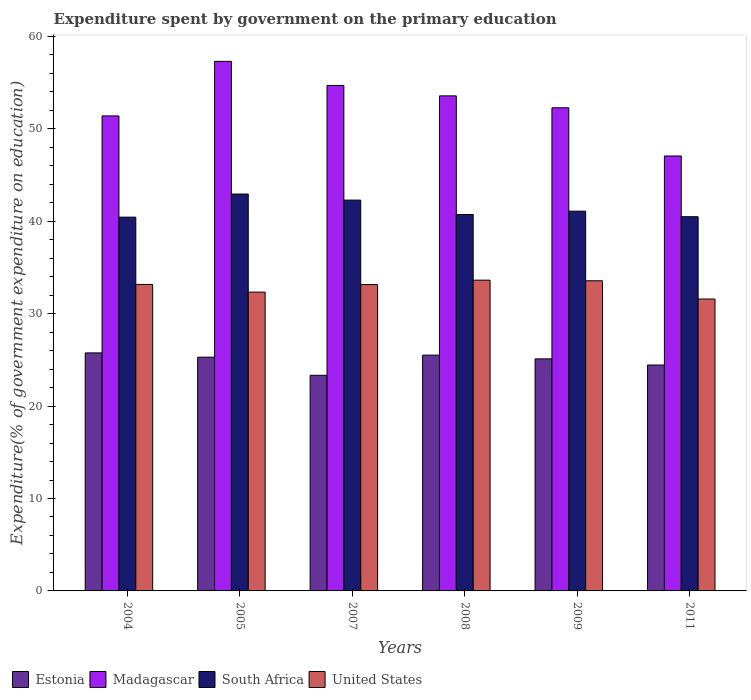How many groups of bars are there?
Provide a short and direct response. 6. What is the expenditure spent by government on the primary education in United States in 2009?
Provide a short and direct response. 33.56. Across all years, what is the maximum expenditure spent by government on the primary education in South Africa?
Provide a succinct answer. 42.95. Across all years, what is the minimum expenditure spent by government on the primary education in Estonia?
Ensure brevity in your answer.  23.33. In which year was the expenditure spent by government on the primary education in United States maximum?
Offer a very short reply. 2008. What is the total expenditure spent by government on the primary education in United States in the graph?
Keep it short and to the point. 197.42. What is the difference between the expenditure spent by government on the primary education in Estonia in 2005 and that in 2009?
Give a very brief answer. 0.18. What is the difference between the expenditure spent by government on the primary education in United States in 2011 and the expenditure spent by government on the primary education in Madagascar in 2009?
Give a very brief answer. -20.7. What is the average expenditure spent by government on the primary education in South Africa per year?
Your answer should be compact. 41.33. In the year 2011, what is the difference between the expenditure spent by government on the primary education in Madagascar and expenditure spent by government on the primary education in Estonia?
Provide a short and direct response. 22.62. In how many years, is the expenditure spent by government on the primary education in South Africa greater than 36 %?
Give a very brief answer. 6. What is the ratio of the expenditure spent by government on the primary education in Estonia in 2004 to that in 2009?
Give a very brief answer. 1.03. Is the expenditure spent by government on the primary education in Madagascar in 2008 less than that in 2011?
Offer a very short reply. No. What is the difference between the highest and the second highest expenditure spent by government on the primary education in South Africa?
Keep it short and to the point. 0.66. What is the difference between the highest and the lowest expenditure spent by government on the primary education in South Africa?
Your answer should be compact. 2.5. What does the 2nd bar from the left in 2011 represents?
Offer a terse response. Madagascar. What does the 3rd bar from the right in 2008 represents?
Your response must be concise. Madagascar. Is it the case that in every year, the sum of the expenditure spent by government on the primary education in United States and expenditure spent by government on the primary education in South Africa is greater than the expenditure spent by government on the primary education in Estonia?
Ensure brevity in your answer.  Yes. How many bars are there?
Provide a succinct answer. 24. How many years are there in the graph?
Your answer should be compact. 6. What is the difference between two consecutive major ticks on the Y-axis?
Offer a terse response. 10. Are the values on the major ticks of Y-axis written in scientific E-notation?
Your response must be concise. No. How many legend labels are there?
Give a very brief answer. 4. How are the legend labels stacked?
Your answer should be very brief. Horizontal. What is the title of the graph?
Give a very brief answer. Expenditure spent by government on the primary education. What is the label or title of the Y-axis?
Offer a very short reply. Expenditure(% of government expenditure on education). What is the Expenditure(% of government expenditure on education) in Estonia in 2004?
Keep it short and to the point. 25.76. What is the Expenditure(% of government expenditure on education) of Madagascar in 2004?
Provide a succinct answer. 51.4. What is the Expenditure(% of government expenditure on education) of South Africa in 2004?
Offer a very short reply. 40.45. What is the Expenditure(% of government expenditure on education) of United States in 2004?
Provide a succinct answer. 33.16. What is the Expenditure(% of government expenditure on education) of Estonia in 2005?
Provide a succinct answer. 25.3. What is the Expenditure(% of government expenditure on education) of Madagascar in 2005?
Offer a very short reply. 57.31. What is the Expenditure(% of government expenditure on education) of South Africa in 2005?
Your answer should be compact. 42.95. What is the Expenditure(% of government expenditure on education) in United States in 2005?
Keep it short and to the point. 32.33. What is the Expenditure(% of government expenditure on education) of Estonia in 2007?
Ensure brevity in your answer.  23.33. What is the Expenditure(% of government expenditure on education) in Madagascar in 2007?
Keep it short and to the point. 54.7. What is the Expenditure(% of government expenditure on education) of South Africa in 2007?
Provide a succinct answer. 42.29. What is the Expenditure(% of government expenditure on education) in United States in 2007?
Keep it short and to the point. 33.15. What is the Expenditure(% of government expenditure on education) of Estonia in 2008?
Ensure brevity in your answer.  25.52. What is the Expenditure(% of government expenditure on education) in Madagascar in 2008?
Make the answer very short. 53.57. What is the Expenditure(% of government expenditure on education) in South Africa in 2008?
Provide a succinct answer. 40.73. What is the Expenditure(% of government expenditure on education) of United States in 2008?
Your answer should be compact. 33.63. What is the Expenditure(% of government expenditure on education) of Estonia in 2009?
Your answer should be very brief. 25.11. What is the Expenditure(% of government expenditure on education) of Madagascar in 2009?
Offer a very short reply. 52.28. What is the Expenditure(% of government expenditure on education) in South Africa in 2009?
Provide a short and direct response. 41.09. What is the Expenditure(% of government expenditure on education) of United States in 2009?
Your answer should be very brief. 33.56. What is the Expenditure(% of government expenditure on education) of Estonia in 2011?
Offer a very short reply. 24.45. What is the Expenditure(% of government expenditure on education) in Madagascar in 2011?
Give a very brief answer. 47.07. What is the Expenditure(% of government expenditure on education) of South Africa in 2011?
Provide a short and direct response. 40.49. What is the Expenditure(% of government expenditure on education) of United States in 2011?
Your answer should be very brief. 31.59. Across all years, what is the maximum Expenditure(% of government expenditure on education) of Estonia?
Keep it short and to the point. 25.76. Across all years, what is the maximum Expenditure(% of government expenditure on education) in Madagascar?
Provide a short and direct response. 57.31. Across all years, what is the maximum Expenditure(% of government expenditure on education) of South Africa?
Your response must be concise. 42.95. Across all years, what is the maximum Expenditure(% of government expenditure on education) in United States?
Your answer should be compact. 33.63. Across all years, what is the minimum Expenditure(% of government expenditure on education) of Estonia?
Offer a terse response. 23.33. Across all years, what is the minimum Expenditure(% of government expenditure on education) of Madagascar?
Offer a terse response. 47.07. Across all years, what is the minimum Expenditure(% of government expenditure on education) in South Africa?
Your response must be concise. 40.45. Across all years, what is the minimum Expenditure(% of government expenditure on education) in United States?
Give a very brief answer. 31.59. What is the total Expenditure(% of government expenditure on education) in Estonia in the graph?
Your answer should be compact. 149.46. What is the total Expenditure(% of government expenditure on education) of Madagascar in the graph?
Ensure brevity in your answer.  316.33. What is the total Expenditure(% of government expenditure on education) of South Africa in the graph?
Your answer should be very brief. 248.01. What is the total Expenditure(% of government expenditure on education) in United States in the graph?
Make the answer very short. 197.42. What is the difference between the Expenditure(% of government expenditure on education) in Estonia in 2004 and that in 2005?
Give a very brief answer. 0.46. What is the difference between the Expenditure(% of government expenditure on education) in Madagascar in 2004 and that in 2005?
Keep it short and to the point. -5.9. What is the difference between the Expenditure(% of government expenditure on education) in South Africa in 2004 and that in 2005?
Ensure brevity in your answer.  -2.5. What is the difference between the Expenditure(% of government expenditure on education) in United States in 2004 and that in 2005?
Keep it short and to the point. 0.83. What is the difference between the Expenditure(% of government expenditure on education) in Estonia in 2004 and that in 2007?
Your answer should be very brief. 2.42. What is the difference between the Expenditure(% of government expenditure on education) in Madagascar in 2004 and that in 2007?
Your answer should be compact. -3.3. What is the difference between the Expenditure(% of government expenditure on education) in South Africa in 2004 and that in 2007?
Provide a short and direct response. -1.85. What is the difference between the Expenditure(% of government expenditure on education) of United States in 2004 and that in 2007?
Provide a short and direct response. 0.02. What is the difference between the Expenditure(% of government expenditure on education) in Estonia in 2004 and that in 2008?
Ensure brevity in your answer.  0.24. What is the difference between the Expenditure(% of government expenditure on education) in Madagascar in 2004 and that in 2008?
Provide a short and direct response. -2.17. What is the difference between the Expenditure(% of government expenditure on education) in South Africa in 2004 and that in 2008?
Your answer should be very brief. -0.29. What is the difference between the Expenditure(% of government expenditure on education) in United States in 2004 and that in 2008?
Give a very brief answer. -0.46. What is the difference between the Expenditure(% of government expenditure on education) of Estonia in 2004 and that in 2009?
Your answer should be compact. 0.65. What is the difference between the Expenditure(% of government expenditure on education) in Madagascar in 2004 and that in 2009?
Your response must be concise. -0.88. What is the difference between the Expenditure(% of government expenditure on education) in South Africa in 2004 and that in 2009?
Offer a terse response. -0.65. What is the difference between the Expenditure(% of government expenditure on education) in United States in 2004 and that in 2009?
Your answer should be compact. -0.4. What is the difference between the Expenditure(% of government expenditure on education) of Estonia in 2004 and that in 2011?
Keep it short and to the point. 1.31. What is the difference between the Expenditure(% of government expenditure on education) in Madagascar in 2004 and that in 2011?
Your answer should be very brief. 4.34. What is the difference between the Expenditure(% of government expenditure on education) in South Africa in 2004 and that in 2011?
Provide a short and direct response. -0.05. What is the difference between the Expenditure(% of government expenditure on education) of United States in 2004 and that in 2011?
Your response must be concise. 1.58. What is the difference between the Expenditure(% of government expenditure on education) of Estonia in 2005 and that in 2007?
Your answer should be very brief. 1.96. What is the difference between the Expenditure(% of government expenditure on education) of Madagascar in 2005 and that in 2007?
Make the answer very short. 2.61. What is the difference between the Expenditure(% of government expenditure on education) of South Africa in 2005 and that in 2007?
Your response must be concise. 0.66. What is the difference between the Expenditure(% of government expenditure on education) of United States in 2005 and that in 2007?
Offer a terse response. -0.81. What is the difference between the Expenditure(% of government expenditure on education) of Estonia in 2005 and that in 2008?
Provide a short and direct response. -0.22. What is the difference between the Expenditure(% of government expenditure on education) in Madagascar in 2005 and that in 2008?
Your answer should be compact. 3.73. What is the difference between the Expenditure(% of government expenditure on education) in South Africa in 2005 and that in 2008?
Provide a short and direct response. 2.21. What is the difference between the Expenditure(% of government expenditure on education) of United States in 2005 and that in 2008?
Keep it short and to the point. -1.29. What is the difference between the Expenditure(% of government expenditure on education) of Estonia in 2005 and that in 2009?
Provide a succinct answer. 0.18. What is the difference between the Expenditure(% of government expenditure on education) in Madagascar in 2005 and that in 2009?
Keep it short and to the point. 5.02. What is the difference between the Expenditure(% of government expenditure on education) of South Africa in 2005 and that in 2009?
Your answer should be very brief. 1.85. What is the difference between the Expenditure(% of government expenditure on education) of United States in 2005 and that in 2009?
Give a very brief answer. -1.23. What is the difference between the Expenditure(% of government expenditure on education) of Estonia in 2005 and that in 2011?
Your answer should be very brief. 0.85. What is the difference between the Expenditure(% of government expenditure on education) in Madagascar in 2005 and that in 2011?
Your answer should be very brief. 10.24. What is the difference between the Expenditure(% of government expenditure on education) in South Africa in 2005 and that in 2011?
Keep it short and to the point. 2.45. What is the difference between the Expenditure(% of government expenditure on education) in United States in 2005 and that in 2011?
Offer a very short reply. 0.75. What is the difference between the Expenditure(% of government expenditure on education) of Estonia in 2007 and that in 2008?
Make the answer very short. -2.18. What is the difference between the Expenditure(% of government expenditure on education) of Madagascar in 2007 and that in 2008?
Provide a succinct answer. 1.13. What is the difference between the Expenditure(% of government expenditure on education) in South Africa in 2007 and that in 2008?
Your answer should be very brief. 1.56. What is the difference between the Expenditure(% of government expenditure on education) of United States in 2007 and that in 2008?
Your answer should be very brief. -0.48. What is the difference between the Expenditure(% of government expenditure on education) of Estonia in 2007 and that in 2009?
Offer a very short reply. -1.78. What is the difference between the Expenditure(% of government expenditure on education) of Madagascar in 2007 and that in 2009?
Give a very brief answer. 2.42. What is the difference between the Expenditure(% of government expenditure on education) in South Africa in 2007 and that in 2009?
Ensure brevity in your answer.  1.2. What is the difference between the Expenditure(% of government expenditure on education) in United States in 2007 and that in 2009?
Give a very brief answer. -0.41. What is the difference between the Expenditure(% of government expenditure on education) in Estonia in 2007 and that in 2011?
Keep it short and to the point. -1.11. What is the difference between the Expenditure(% of government expenditure on education) of Madagascar in 2007 and that in 2011?
Your response must be concise. 7.63. What is the difference between the Expenditure(% of government expenditure on education) of South Africa in 2007 and that in 2011?
Offer a terse response. 1.8. What is the difference between the Expenditure(% of government expenditure on education) of United States in 2007 and that in 2011?
Your answer should be very brief. 1.56. What is the difference between the Expenditure(% of government expenditure on education) of Estonia in 2008 and that in 2009?
Your response must be concise. 0.4. What is the difference between the Expenditure(% of government expenditure on education) in Madagascar in 2008 and that in 2009?
Make the answer very short. 1.29. What is the difference between the Expenditure(% of government expenditure on education) of South Africa in 2008 and that in 2009?
Make the answer very short. -0.36. What is the difference between the Expenditure(% of government expenditure on education) in United States in 2008 and that in 2009?
Offer a terse response. 0.07. What is the difference between the Expenditure(% of government expenditure on education) in Estonia in 2008 and that in 2011?
Provide a succinct answer. 1.07. What is the difference between the Expenditure(% of government expenditure on education) of Madagascar in 2008 and that in 2011?
Provide a short and direct response. 6.51. What is the difference between the Expenditure(% of government expenditure on education) of South Africa in 2008 and that in 2011?
Offer a very short reply. 0.24. What is the difference between the Expenditure(% of government expenditure on education) of United States in 2008 and that in 2011?
Your answer should be compact. 2.04. What is the difference between the Expenditure(% of government expenditure on education) in Estonia in 2009 and that in 2011?
Your answer should be compact. 0.67. What is the difference between the Expenditure(% of government expenditure on education) of Madagascar in 2009 and that in 2011?
Offer a terse response. 5.22. What is the difference between the Expenditure(% of government expenditure on education) in South Africa in 2009 and that in 2011?
Ensure brevity in your answer.  0.6. What is the difference between the Expenditure(% of government expenditure on education) of United States in 2009 and that in 2011?
Give a very brief answer. 1.97. What is the difference between the Expenditure(% of government expenditure on education) of Estonia in 2004 and the Expenditure(% of government expenditure on education) of Madagascar in 2005?
Provide a short and direct response. -31.55. What is the difference between the Expenditure(% of government expenditure on education) of Estonia in 2004 and the Expenditure(% of government expenditure on education) of South Africa in 2005?
Give a very brief answer. -17.19. What is the difference between the Expenditure(% of government expenditure on education) of Estonia in 2004 and the Expenditure(% of government expenditure on education) of United States in 2005?
Your answer should be very brief. -6.58. What is the difference between the Expenditure(% of government expenditure on education) of Madagascar in 2004 and the Expenditure(% of government expenditure on education) of South Africa in 2005?
Keep it short and to the point. 8.45. What is the difference between the Expenditure(% of government expenditure on education) in Madagascar in 2004 and the Expenditure(% of government expenditure on education) in United States in 2005?
Provide a short and direct response. 19.07. What is the difference between the Expenditure(% of government expenditure on education) in South Africa in 2004 and the Expenditure(% of government expenditure on education) in United States in 2005?
Offer a very short reply. 8.11. What is the difference between the Expenditure(% of government expenditure on education) of Estonia in 2004 and the Expenditure(% of government expenditure on education) of Madagascar in 2007?
Offer a very short reply. -28.94. What is the difference between the Expenditure(% of government expenditure on education) in Estonia in 2004 and the Expenditure(% of government expenditure on education) in South Africa in 2007?
Your answer should be very brief. -16.53. What is the difference between the Expenditure(% of government expenditure on education) in Estonia in 2004 and the Expenditure(% of government expenditure on education) in United States in 2007?
Your response must be concise. -7.39. What is the difference between the Expenditure(% of government expenditure on education) of Madagascar in 2004 and the Expenditure(% of government expenditure on education) of South Africa in 2007?
Offer a very short reply. 9.11. What is the difference between the Expenditure(% of government expenditure on education) of Madagascar in 2004 and the Expenditure(% of government expenditure on education) of United States in 2007?
Your answer should be compact. 18.25. What is the difference between the Expenditure(% of government expenditure on education) in South Africa in 2004 and the Expenditure(% of government expenditure on education) in United States in 2007?
Your response must be concise. 7.3. What is the difference between the Expenditure(% of government expenditure on education) in Estonia in 2004 and the Expenditure(% of government expenditure on education) in Madagascar in 2008?
Ensure brevity in your answer.  -27.81. What is the difference between the Expenditure(% of government expenditure on education) in Estonia in 2004 and the Expenditure(% of government expenditure on education) in South Africa in 2008?
Your answer should be compact. -14.98. What is the difference between the Expenditure(% of government expenditure on education) of Estonia in 2004 and the Expenditure(% of government expenditure on education) of United States in 2008?
Keep it short and to the point. -7.87. What is the difference between the Expenditure(% of government expenditure on education) in Madagascar in 2004 and the Expenditure(% of government expenditure on education) in South Africa in 2008?
Your answer should be very brief. 10.67. What is the difference between the Expenditure(% of government expenditure on education) in Madagascar in 2004 and the Expenditure(% of government expenditure on education) in United States in 2008?
Provide a succinct answer. 17.77. What is the difference between the Expenditure(% of government expenditure on education) in South Africa in 2004 and the Expenditure(% of government expenditure on education) in United States in 2008?
Make the answer very short. 6.82. What is the difference between the Expenditure(% of government expenditure on education) in Estonia in 2004 and the Expenditure(% of government expenditure on education) in Madagascar in 2009?
Your answer should be compact. -26.52. What is the difference between the Expenditure(% of government expenditure on education) in Estonia in 2004 and the Expenditure(% of government expenditure on education) in South Africa in 2009?
Your response must be concise. -15.34. What is the difference between the Expenditure(% of government expenditure on education) in Estonia in 2004 and the Expenditure(% of government expenditure on education) in United States in 2009?
Provide a succinct answer. -7.8. What is the difference between the Expenditure(% of government expenditure on education) in Madagascar in 2004 and the Expenditure(% of government expenditure on education) in South Africa in 2009?
Give a very brief answer. 10.31. What is the difference between the Expenditure(% of government expenditure on education) of Madagascar in 2004 and the Expenditure(% of government expenditure on education) of United States in 2009?
Ensure brevity in your answer.  17.84. What is the difference between the Expenditure(% of government expenditure on education) in South Africa in 2004 and the Expenditure(% of government expenditure on education) in United States in 2009?
Offer a very short reply. 6.88. What is the difference between the Expenditure(% of government expenditure on education) of Estonia in 2004 and the Expenditure(% of government expenditure on education) of Madagascar in 2011?
Give a very brief answer. -21.31. What is the difference between the Expenditure(% of government expenditure on education) of Estonia in 2004 and the Expenditure(% of government expenditure on education) of South Africa in 2011?
Your answer should be very brief. -14.74. What is the difference between the Expenditure(% of government expenditure on education) of Estonia in 2004 and the Expenditure(% of government expenditure on education) of United States in 2011?
Your answer should be compact. -5.83. What is the difference between the Expenditure(% of government expenditure on education) in Madagascar in 2004 and the Expenditure(% of government expenditure on education) in South Africa in 2011?
Offer a terse response. 10.91. What is the difference between the Expenditure(% of government expenditure on education) of Madagascar in 2004 and the Expenditure(% of government expenditure on education) of United States in 2011?
Your answer should be compact. 19.82. What is the difference between the Expenditure(% of government expenditure on education) of South Africa in 2004 and the Expenditure(% of government expenditure on education) of United States in 2011?
Your answer should be very brief. 8.86. What is the difference between the Expenditure(% of government expenditure on education) in Estonia in 2005 and the Expenditure(% of government expenditure on education) in Madagascar in 2007?
Your answer should be compact. -29.4. What is the difference between the Expenditure(% of government expenditure on education) in Estonia in 2005 and the Expenditure(% of government expenditure on education) in South Africa in 2007?
Make the answer very short. -17. What is the difference between the Expenditure(% of government expenditure on education) of Estonia in 2005 and the Expenditure(% of government expenditure on education) of United States in 2007?
Offer a very short reply. -7.85. What is the difference between the Expenditure(% of government expenditure on education) in Madagascar in 2005 and the Expenditure(% of government expenditure on education) in South Africa in 2007?
Ensure brevity in your answer.  15.01. What is the difference between the Expenditure(% of government expenditure on education) in Madagascar in 2005 and the Expenditure(% of government expenditure on education) in United States in 2007?
Your answer should be compact. 24.16. What is the difference between the Expenditure(% of government expenditure on education) in South Africa in 2005 and the Expenditure(% of government expenditure on education) in United States in 2007?
Your answer should be compact. 9.8. What is the difference between the Expenditure(% of government expenditure on education) in Estonia in 2005 and the Expenditure(% of government expenditure on education) in Madagascar in 2008?
Offer a terse response. -28.28. What is the difference between the Expenditure(% of government expenditure on education) of Estonia in 2005 and the Expenditure(% of government expenditure on education) of South Africa in 2008?
Your answer should be compact. -15.44. What is the difference between the Expenditure(% of government expenditure on education) in Estonia in 2005 and the Expenditure(% of government expenditure on education) in United States in 2008?
Your answer should be very brief. -8.33. What is the difference between the Expenditure(% of government expenditure on education) of Madagascar in 2005 and the Expenditure(% of government expenditure on education) of South Africa in 2008?
Make the answer very short. 16.57. What is the difference between the Expenditure(% of government expenditure on education) of Madagascar in 2005 and the Expenditure(% of government expenditure on education) of United States in 2008?
Ensure brevity in your answer.  23.68. What is the difference between the Expenditure(% of government expenditure on education) of South Africa in 2005 and the Expenditure(% of government expenditure on education) of United States in 2008?
Ensure brevity in your answer.  9.32. What is the difference between the Expenditure(% of government expenditure on education) in Estonia in 2005 and the Expenditure(% of government expenditure on education) in Madagascar in 2009?
Your answer should be very brief. -26.99. What is the difference between the Expenditure(% of government expenditure on education) in Estonia in 2005 and the Expenditure(% of government expenditure on education) in South Africa in 2009?
Your answer should be very brief. -15.8. What is the difference between the Expenditure(% of government expenditure on education) of Estonia in 2005 and the Expenditure(% of government expenditure on education) of United States in 2009?
Provide a succinct answer. -8.27. What is the difference between the Expenditure(% of government expenditure on education) of Madagascar in 2005 and the Expenditure(% of government expenditure on education) of South Africa in 2009?
Provide a succinct answer. 16.21. What is the difference between the Expenditure(% of government expenditure on education) in Madagascar in 2005 and the Expenditure(% of government expenditure on education) in United States in 2009?
Keep it short and to the point. 23.74. What is the difference between the Expenditure(% of government expenditure on education) in South Africa in 2005 and the Expenditure(% of government expenditure on education) in United States in 2009?
Provide a short and direct response. 9.39. What is the difference between the Expenditure(% of government expenditure on education) in Estonia in 2005 and the Expenditure(% of government expenditure on education) in Madagascar in 2011?
Ensure brevity in your answer.  -21.77. What is the difference between the Expenditure(% of government expenditure on education) in Estonia in 2005 and the Expenditure(% of government expenditure on education) in South Africa in 2011?
Your response must be concise. -15.2. What is the difference between the Expenditure(% of government expenditure on education) in Estonia in 2005 and the Expenditure(% of government expenditure on education) in United States in 2011?
Keep it short and to the point. -6.29. What is the difference between the Expenditure(% of government expenditure on education) of Madagascar in 2005 and the Expenditure(% of government expenditure on education) of South Africa in 2011?
Make the answer very short. 16.81. What is the difference between the Expenditure(% of government expenditure on education) of Madagascar in 2005 and the Expenditure(% of government expenditure on education) of United States in 2011?
Your answer should be compact. 25.72. What is the difference between the Expenditure(% of government expenditure on education) in South Africa in 2005 and the Expenditure(% of government expenditure on education) in United States in 2011?
Make the answer very short. 11.36. What is the difference between the Expenditure(% of government expenditure on education) in Estonia in 2007 and the Expenditure(% of government expenditure on education) in Madagascar in 2008?
Keep it short and to the point. -30.24. What is the difference between the Expenditure(% of government expenditure on education) in Estonia in 2007 and the Expenditure(% of government expenditure on education) in South Africa in 2008?
Ensure brevity in your answer.  -17.4. What is the difference between the Expenditure(% of government expenditure on education) of Estonia in 2007 and the Expenditure(% of government expenditure on education) of United States in 2008?
Your answer should be compact. -10.29. What is the difference between the Expenditure(% of government expenditure on education) in Madagascar in 2007 and the Expenditure(% of government expenditure on education) in South Africa in 2008?
Ensure brevity in your answer.  13.97. What is the difference between the Expenditure(% of government expenditure on education) of Madagascar in 2007 and the Expenditure(% of government expenditure on education) of United States in 2008?
Offer a very short reply. 21.07. What is the difference between the Expenditure(% of government expenditure on education) of South Africa in 2007 and the Expenditure(% of government expenditure on education) of United States in 2008?
Make the answer very short. 8.66. What is the difference between the Expenditure(% of government expenditure on education) in Estonia in 2007 and the Expenditure(% of government expenditure on education) in Madagascar in 2009?
Give a very brief answer. -28.95. What is the difference between the Expenditure(% of government expenditure on education) in Estonia in 2007 and the Expenditure(% of government expenditure on education) in South Africa in 2009?
Give a very brief answer. -17.76. What is the difference between the Expenditure(% of government expenditure on education) of Estonia in 2007 and the Expenditure(% of government expenditure on education) of United States in 2009?
Provide a succinct answer. -10.23. What is the difference between the Expenditure(% of government expenditure on education) of Madagascar in 2007 and the Expenditure(% of government expenditure on education) of South Africa in 2009?
Provide a short and direct response. 13.6. What is the difference between the Expenditure(% of government expenditure on education) in Madagascar in 2007 and the Expenditure(% of government expenditure on education) in United States in 2009?
Make the answer very short. 21.14. What is the difference between the Expenditure(% of government expenditure on education) in South Africa in 2007 and the Expenditure(% of government expenditure on education) in United States in 2009?
Your answer should be compact. 8.73. What is the difference between the Expenditure(% of government expenditure on education) in Estonia in 2007 and the Expenditure(% of government expenditure on education) in Madagascar in 2011?
Ensure brevity in your answer.  -23.73. What is the difference between the Expenditure(% of government expenditure on education) in Estonia in 2007 and the Expenditure(% of government expenditure on education) in South Africa in 2011?
Your response must be concise. -17.16. What is the difference between the Expenditure(% of government expenditure on education) in Estonia in 2007 and the Expenditure(% of government expenditure on education) in United States in 2011?
Provide a succinct answer. -8.25. What is the difference between the Expenditure(% of government expenditure on education) of Madagascar in 2007 and the Expenditure(% of government expenditure on education) of South Africa in 2011?
Make the answer very short. 14.21. What is the difference between the Expenditure(% of government expenditure on education) in Madagascar in 2007 and the Expenditure(% of government expenditure on education) in United States in 2011?
Ensure brevity in your answer.  23.11. What is the difference between the Expenditure(% of government expenditure on education) of South Africa in 2007 and the Expenditure(% of government expenditure on education) of United States in 2011?
Provide a succinct answer. 10.7. What is the difference between the Expenditure(% of government expenditure on education) of Estonia in 2008 and the Expenditure(% of government expenditure on education) of Madagascar in 2009?
Your answer should be very brief. -26.77. What is the difference between the Expenditure(% of government expenditure on education) in Estonia in 2008 and the Expenditure(% of government expenditure on education) in South Africa in 2009?
Ensure brevity in your answer.  -15.58. What is the difference between the Expenditure(% of government expenditure on education) in Estonia in 2008 and the Expenditure(% of government expenditure on education) in United States in 2009?
Provide a short and direct response. -8.05. What is the difference between the Expenditure(% of government expenditure on education) in Madagascar in 2008 and the Expenditure(% of government expenditure on education) in South Africa in 2009?
Ensure brevity in your answer.  12.48. What is the difference between the Expenditure(% of government expenditure on education) of Madagascar in 2008 and the Expenditure(% of government expenditure on education) of United States in 2009?
Your response must be concise. 20.01. What is the difference between the Expenditure(% of government expenditure on education) of South Africa in 2008 and the Expenditure(% of government expenditure on education) of United States in 2009?
Make the answer very short. 7.17. What is the difference between the Expenditure(% of government expenditure on education) of Estonia in 2008 and the Expenditure(% of government expenditure on education) of Madagascar in 2011?
Offer a terse response. -21.55. What is the difference between the Expenditure(% of government expenditure on education) of Estonia in 2008 and the Expenditure(% of government expenditure on education) of South Africa in 2011?
Your answer should be compact. -14.98. What is the difference between the Expenditure(% of government expenditure on education) of Estonia in 2008 and the Expenditure(% of government expenditure on education) of United States in 2011?
Your response must be concise. -6.07. What is the difference between the Expenditure(% of government expenditure on education) of Madagascar in 2008 and the Expenditure(% of government expenditure on education) of South Africa in 2011?
Offer a terse response. 13.08. What is the difference between the Expenditure(% of government expenditure on education) in Madagascar in 2008 and the Expenditure(% of government expenditure on education) in United States in 2011?
Make the answer very short. 21.99. What is the difference between the Expenditure(% of government expenditure on education) in South Africa in 2008 and the Expenditure(% of government expenditure on education) in United States in 2011?
Offer a very short reply. 9.15. What is the difference between the Expenditure(% of government expenditure on education) in Estonia in 2009 and the Expenditure(% of government expenditure on education) in Madagascar in 2011?
Make the answer very short. -21.95. What is the difference between the Expenditure(% of government expenditure on education) in Estonia in 2009 and the Expenditure(% of government expenditure on education) in South Africa in 2011?
Make the answer very short. -15.38. What is the difference between the Expenditure(% of government expenditure on education) of Estonia in 2009 and the Expenditure(% of government expenditure on education) of United States in 2011?
Provide a succinct answer. -6.47. What is the difference between the Expenditure(% of government expenditure on education) in Madagascar in 2009 and the Expenditure(% of government expenditure on education) in South Africa in 2011?
Offer a very short reply. 11.79. What is the difference between the Expenditure(% of government expenditure on education) in Madagascar in 2009 and the Expenditure(% of government expenditure on education) in United States in 2011?
Provide a short and direct response. 20.7. What is the difference between the Expenditure(% of government expenditure on education) in South Africa in 2009 and the Expenditure(% of government expenditure on education) in United States in 2011?
Ensure brevity in your answer.  9.51. What is the average Expenditure(% of government expenditure on education) in Estonia per year?
Offer a terse response. 24.91. What is the average Expenditure(% of government expenditure on education) in Madagascar per year?
Make the answer very short. 52.72. What is the average Expenditure(% of government expenditure on education) of South Africa per year?
Keep it short and to the point. 41.33. What is the average Expenditure(% of government expenditure on education) of United States per year?
Offer a terse response. 32.9. In the year 2004, what is the difference between the Expenditure(% of government expenditure on education) in Estonia and Expenditure(% of government expenditure on education) in Madagascar?
Your answer should be compact. -25.65. In the year 2004, what is the difference between the Expenditure(% of government expenditure on education) of Estonia and Expenditure(% of government expenditure on education) of South Africa?
Offer a terse response. -14.69. In the year 2004, what is the difference between the Expenditure(% of government expenditure on education) of Estonia and Expenditure(% of government expenditure on education) of United States?
Ensure brevity in your answer.  -7.41. In the year 2004, what is the difference between the Expenditure(% of government expenditure on education) of Madagascar and Expenditure(% of government expenditure on education) of South Africa?
Your answer should be compact. 10.96. In the year 2004, what is the difference between the Expenditure(% of government expenditure on education) of Madagascar and Expenditure(% of government expenditure on education) of United States?
Provide a succinct answer. 18.24. In the year 2004, what is the difference between the Expenditure(% of government expenditure on education) of South Africa and Expenditure(% of government expenditure on education) of United States?
Your response must be concise. 7.28. In the year 2005, what is the difference between the Expenditure(% of government expenditure on education) of Estonia and Expenditure(% of government expenditure on education) of Madagascar?
Provide a succinct answer. -32.01. In the year 2005, what is the difference between the Expenditure(% of government expenditure on education) of Estonia and Expenditure(% of government expenditure on education) of South Africa?
Ensure brevity in your answer.  -17.65. In the year 2005, what is the difference between the Expenditure(% of government expenditure on education) of Estonia and Expenditure(% of government expenditure on education) of United States?
Keep it short and to the point. -7.04. In the year 2005, what is the difference between the Expenditure(% of government expenditure on education) in Madagascar and Expenditure(% of government expenditure on education) in South Africa?
Keep it short and to the point. 14.36. In the year 2005, what is the difference between the Expenditure(% of government expenditure on education) in Madagascar and Expenditure(% of government expenditure on education) in United States?
Provide a succinct answer. 24.97. In the year 2005, what is the difference between the Expenditure(% of government expenditure on education) in South Africa and Expenditure(% of government expenditure on education) in United States?
Keep it short and to the point. 10.61. In the year 2007, what is the difference between the Expenditure(% of government expenditure on education) of Estonia and Expenditure(% of government expenditure on education) of Madagascar?
Your answer should be very brief. -31.37. In the year 2007, what is the difference between the Expenditure(% of government expenditure on education) of Estonia and Expenditure(% of government expenditure on education) of South Africa?
Offer a very short reply. -18.96. In the year 2007, what is the difference between the Expenditure(% of government expenditure on education) of Estonia and Expenditure(% of government expenditure on education) of United States?
Your answer should be compact. -9.81. In the year 2007, what is the difference between the Expenditure(% of government expenditure on education) in Madagascar and Expenditure(% of government expenditure on education) in South Africa?
Ensure brevity in your answer.  12.41. In the year 2007, what is the difference between the Expenditure(% of government expenditure on education) in Madagascar and Expenditure(% of government expenditure on education) in United States?
Provide a succinct answer. 21.55. In the year 2007, what is the difference between the Expenditure(% of government expenditure on education) in South Africa and Expenditure(% of government expenditure on education) in United States?
Give a very brief answer. 9.14. In the year 2008, what is the difference between the Expenditure(% of government expenditure on education) of Estonia and Expenditure(% of government expenditure on education) of Madagascar?
Offer a terse response. -28.06. In the year 2008, what is the difference between the Expenditure(% of government expenditure on education) of Estonia and Expenditure(% of government expenditure on education) of South Africa?
Your answer should be compact. -15.22. In the year 2008, what is the difference between the Expenditure(% of government expenditure on education) in Estonia and Expenditure(% of government expenditure on education) in United States?
Provide a short and direct response. -8.11. In the year 2008, what is the difference between the Expenditure(% of government expenditure on education) in Madagascar and Expenditure(% of government expenditure on education) in South Africa?
Offer a terse response. 12.84. In the year 2008, what is the difference between the Expenditure(% of government expenditure on education) in Madagascar and Expenditure(% of government expenditure on education) in United States?
Your response must be concise. 19.94. In the year 2008, what is the difference between the Expenditure(% of government expenditure on education) in South Africa and Expenditure(% of government expenditure on education) in United States?
Offer a very short reply. 7.1. In the year 2009, what is the difference between the Expenditure(% of government expenditure on education) of Estonia and Expenditure(% of government expenditure on education) of Madagascar?
Provide a succinct answer. -27.17. In the year 2009, what is the difference between the Expenditure(% of government expenditure on education) of Estonia and Expenditure(% of government expenditure on education) of South Africa?
Give a very brief answer. -15.98. In the year 2009, what is the difference between the Expenditure(% of government expenditure on education) of Estonia and Expenditure(% of government expenditure on education) of United States?
Offer a very short reply. -8.45. In the year 2009, what is the difference between the Expenditure(% of government expenditure on education) of Madagascar and Expenditure(% of government expenditure on education) of South Africa?
Ensure brevity in your answer.  11.19. In the year 2009, what is the difference between the Expenditure(% of government expenditure on education) in Madagascar and Expenditure(% of government expenditure on education) in United States?
Ensure brevity in your answer.  18.72. In the year 2009, what is the difference between the Expenditure(% of government expenditure on education) in South Africa and Expenditure(% of government expenditure on education) in United States?
Offer a very short reply. 7.53. In the year 2011, what is the difference between the Expenditure(% of government expenditure on education) of Estonia and Expenditure(% of government expenditure on education) of Madagascar?
Offer a terse response. -22.62. In the year 2011, what is the difference between the Expenditure(% of government expenditure on education) of Estonia and Expenditure(% of government expenditure on education) of South Africa?
Provide a short and direct response. -16.05. In the year 2011, what is the difference between the Expenditure(% of government expenditure on education) of Estonia and Expenditure(% of government expenditure on education) of United States?
Provide a short and direct response. -7.14. In the year 2011, what is the difference between the Expenditure(% of government expenditure on education) of Madagascar and Expenditure(% of government expenditure on education) of South Africa?
Keep it short and to the point. 6.57. In the year 2011, what is the difference between the Expenditure(% of government expenditure on education) of Madagascar and Expenditure(% of government expenditure on education) of United States?
Ensure brevity in your answer.  15.48. In the year 2011, what is the difference between the Expenditure(% of government expenditure on education) in South Africa and Expenditure(% of government expenditure on education) in United States?
Provide a succinct answer. 8.91. What is the ratio of the Expenditure(% of government expenditure on education) of Estonia in 2004 to that in 2005?
Offer a very short reply. 1.02. What is the ratio of the Expenditure(% of government expenditure on education) of Madagascar in 2004 to that in 2005?
Keep it short and to the point. 0.9. What is the ratio of the Expenditure(% of government expenditure on education) of South Africa in 2004 to that in 2005?
Provide a short and direct response. 0.94. What is the ratio of the Expenditure(% of government expenditure on education) of United States in 2004 to that in 2005?
Give a very brief answer. 1.03. What is the ratio of the Expenditure(% of government expenditure on education) in Estonia in 2004 to that in 2007?
Your answer should be compact. 1.1. What is the ratio of the Expenditure(% of government expenditure on education) in Madagascar in 2004 to that in 2007?
Your response must be concise. 0.94. What is the ratio of the Expenditure(% of government expenditure on education) of South Africa in 2004 to that in 2007?
Keep it short and to the point. 0.96. What is the ratio of the Expenditure(% of government expenditure on education) of Estonia in 2004 to that in 2008?
Make the answer very short. 1.01. What is the ratio of the Expenditure(% of government expenditure on education) in Madagascar in 2004 to that in 2008?
Keep it short and to the point. 0.96. What is the ratio of the Expenditure(% of government expenditure on education) of United States in 2004 to that in 2008?
Keep it short and to the point. 0.99. What is the ratio of the Expenditure(% of government expenditure on education) of Estonia in 2004 to that in 2009?
Your response must be concise. 1.03. What is the ratio of the Expenditure(% of government expenditure on education) in Madagascar in 2004 to that in 2009?
Offer a terse response. 0.98. What is the ratio of the Expenditure(% of government expenditure on education) of South Africa in 2004 to that in 2009?
Ensure brevity in your answer.  0.98. What is the ratio of the Expenditure(% of government expenditure on education) in Estonia in 2004 to that in 2011?
Your response must be concise. 1.05. What is the ratio of the Expenditure(% of government expenditure on education) in Madagascar in 2004 to that in 2011?
Ensure brevity in your answer.  1.09. What is the ratio of the Expenditure(% of government expenditure on education) of United States in 2004 to that in 2011?
Keep it short and to the point. 1.05. What is the ratio of the Expenditure(% of government expenditure on education) of Estonia in 2005 to that in 2007?
Provide a short and direct response. 1.08. What is the ratio of the Expenditure(% of government expenditure on education) of Madagascar in 2005 to that in 2007?
Offer a very short reply. 1.05. What is the ratio of the Expenditure(% of government expenditure on education) in South Africa in 2005 to that in 2007?
Your answer should be compact. 1.02. What is the ratio of the Expenditure(% of government expenditure on education) of United States in 2005 to that in 2007?
Keep it short and to the point. 0.98. What is the ratio of the Expenditure(% of government expenditure on education) of Estonia in 2005 to that in 2008?
Offer a terse response. 0.99. What is the ratio of the Expenditure(% of government expenditure on education) of Madagascar in 2005 to that in 2008?
Keep it short and to the point. 1.07. What is the ratio of the Expenditure(% of government expenditure on education) of South Africa in 2005 to that in 2008?
Ensure brevity in your answer.  1.05. What is the ratio of the Expenditure(% of government expenditure on education) of United States in 2005 to that in 2008?
Offer a very short reply. 0.96. What is the ratio of the Expenditure(% of government expenditure on education) in Estonia in 2005 to that in 2009?
Provide a succinct answer. 1.01. What is the ratio of the Expenditure(% of government expenditure on education) in Madagascar in 2005 to that in 2009?
Offer a terse response. 1.1. What is the ratio of the Expenditure(% of government expenditure on education) of South Africa in 2005 to that in 2009?
Your response must be concise. 1.05. What is the ratio of the Expenditure(% of government expenditure on education) in United States in 2005 to that in 2009?
Your response must be concise. 0.96. What is the ratio of the Expenditure(% of government expenditure on education) in Estonia in 2005 to that in 2011?
Keep it short and to the point. 1.03. What is the ratio of the Expenditure(% of government expenditure on education) in Madagascar in 2005 to that in 2011?
Give a very brief answer. 1.22. What is the ratio of the Expenditure(% of government expenditure on education) in South Africa in 2005 to that in 2011?
Offer a terse response. 1.06. What is the ratio of the Expenditure(% of government expenditure on education) of United States in 2005 to that in 2011?
Offer a terse response. 1.02. What is the ratio of the Expenditure(% of government expenditure on education) of Estonia in 2007 to that in 2008?
Your answer should be very brief. 0.91. What is the ratio of the Expenditure(% of government expenditure on education) of South Africa in 2007 to that in 2008?
Your response must be concise. 1.04. What is the ratio of the Expenditure(% of government expenditure on education) of United States in 2007 to that in 2008?
Your answer should be very brief. 0.99. What is the ratio of the Expenditure(% of government expenditure on education) in Estonia in 2007 to that in 2009?
Offer a very short reply. 0.93. What is the ratio of the Expenditure(% of government expenditure on education) in Madagascar in 2007 to that in 2009?
Your answer should be very brief. 1.05. What is the ratio of the Expenditure(% of government expenditure on education) in South Africa in 2007 to that in 2009?
Keep it short and to the point. 1.03. What is the ratio of the Expenditure(% of government expenditure on education) in United States in 2007 to that in 2009?
Make the answer very short. 0.99. What is the ratio of the Expenditure(% of government expenditure on education) in Estonia in 2007 to that in 2011?
Offer a terse response. 0.95. What is the ratio of the Expenditure(% of government expenditure on education) in Madagascar in 2007 to that in 2011?
Give a very brief answer. 1.16. What is the ratio of the Expenditure(% of government expenditure on education) of South Africa in 2007 to that in 2011?
Give a very brief answer. 1.04. What is the ratio of the Expenditure(% of government expenditure on education) in United States in 2007 to that in 2011?
Your response must be concise. 1.05. What is the ratio of the Expenditure(% of government expenditure on education) of Estonia in 2008 to that in 2009?
Give a very brief answer. 1.02. What is the ratio of the Expenditure(% of government expenditure on education) of Madagascar in 2008 to that in 2009?
Provide a succinct answer. 1.02. What is the ratio of the Expenditure(% of government expenditure on education) in United States in 2008 to that in 2009?
Provide a short and direct response. 1. What is the ratio of the Expenditure(% of government expenditure on education) in Estonia in 2008 to that in 2011?
Your response must be concise. 1.04. What is the ratio of the Expenditure(% of government expenditure on education) of Madagascar in 2008 to that in 2011?
Your answer should be very brief. 1.14. What is the ratio of the Expenditure(% of government expenditure on education) in South Africa in 2008 to that in 2011?
Provide a short and direct response. 1.01. What is the ratio of the Expenditure(% of government expenditure on education) in United States in 2008 to that in 2011?
Provide a short and direct response. 1.06. What is the ratio of the Expenditure(% of government expenditure on education) in Estonia in 2009 to that in 2011?
Offer a very short reply. 1.03. What is the ratio of the Expenditure(% of government expenditure on education) of Madagascar in 2009 to that in 2011?
Ensure brevity in your answer.  1.11. What is the ratio of the Expenditure(% of government expenditure on education) of South Africa in 2009 to that in 2011?
Provide a short and direct response. 1.01. What is the difference between the highest and the second highest Expenditure(% of government expenditure on education) of Estonia?
Your answer should be very brief. 0.24. What is the difference between the highest and the second highest Expenditure(% of government expenditure on education) in Madagascar?
Your answer should be compact. 2.61. What is the difference between the highest and the second highest Expenditure(% of government expenditure on education) in South Africa?
Keep it short and to the point. 0.66. What is the difference between the highest and the second highest Expenditure(% of government expenditure on education) in United States?
Keep it short and to the point. 0.07. What is the difference between the highest and the lowest Expenditure(% of government expenditure on education) of Estonia?
Provide a succinct answer. 2.42. What is the difference between the highest and the lowest Expenditure(% of government expenditure on education) in Madagascar?
Provide a short and direct response. 10.24. What is the difference between the highest and the lowest Expenditure(% of government expenditure on education) in South Africa?
Offer a terse response. 2.5. What is the difference between the highest and the lowest Expenditure(% of government expenditure on education) in United States?
Keep it short and to the point. 2.04. 